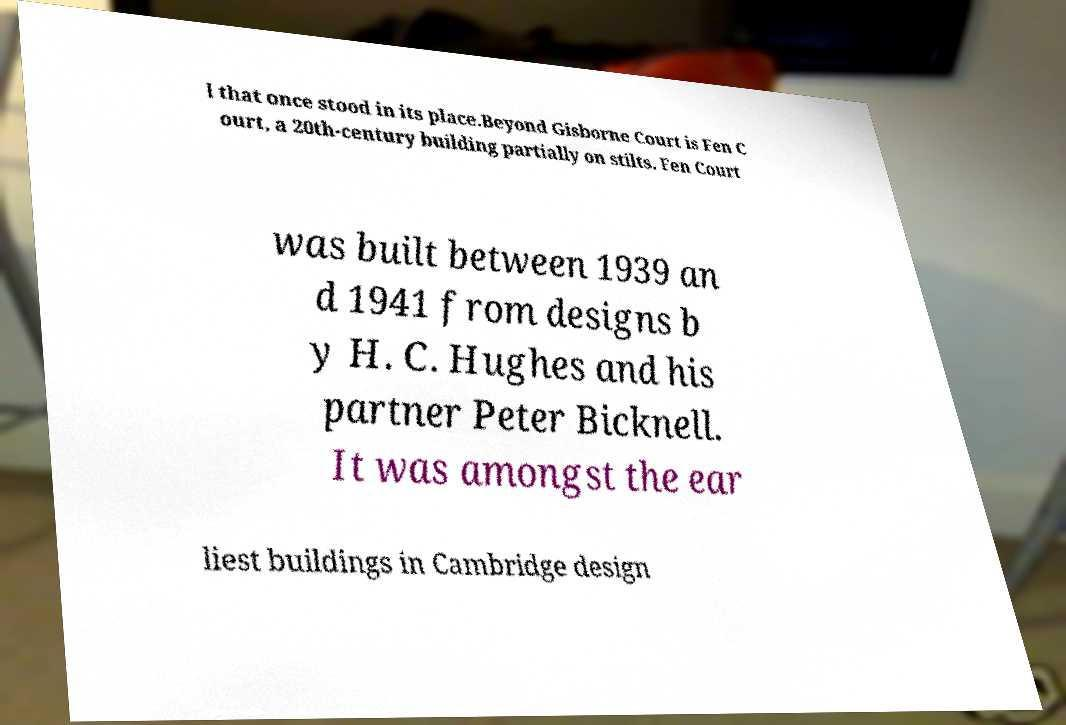Can you read and provide the text displayed in the image?This photo seems to have some interesting text. Can you extract and type it out for me? l that once stood in its place.Beyond Gisborne Court is Fen C ourt, a 20th-century building partially on stilts. Fen Court was built between 1939 an d 1941 from designs b y H. C. Hughes and his partner Peter Bicknell. It was amongst the ear liest buildings in Cambridge design 